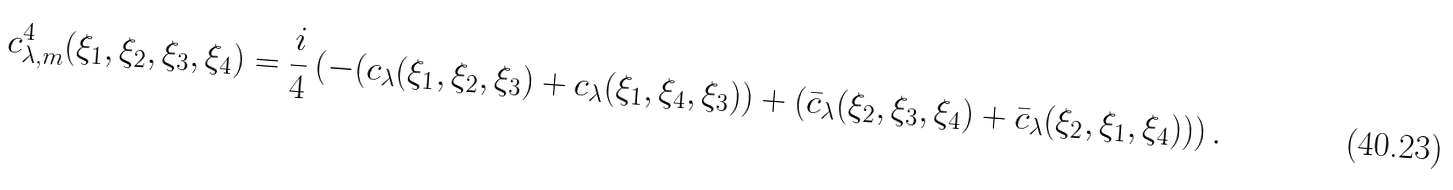<formula> <loc_0><loc_0><loc_500><loc_500>c ^ { 4 } _ { \lambda , m } ( \xi _ { 1 } , \xi _ { 2 } , \xi _ { 3 } , \xi _ { 4 } ) = \frac { i } 4 \left ( - ( c _ { \lambda } ( \xi _ { 1 } , \xi _ { 2 } , \xi _ { 3 } ) + c _ { \lambda } ( \xi _ { 1 } , \xi _ { 4 } , \xi _ { 3 } ) ) + ( \bar { c } _ { \lambda } ( \xi _ { 2 } , \xi _ { 3 } , \xi _ { 4 } ) + \bar { c } _ { \lambda } ( \xi _ { 2 } , \xi _ { 1 } , \xi _ { 4 } ) ) \right ) .</formula> 